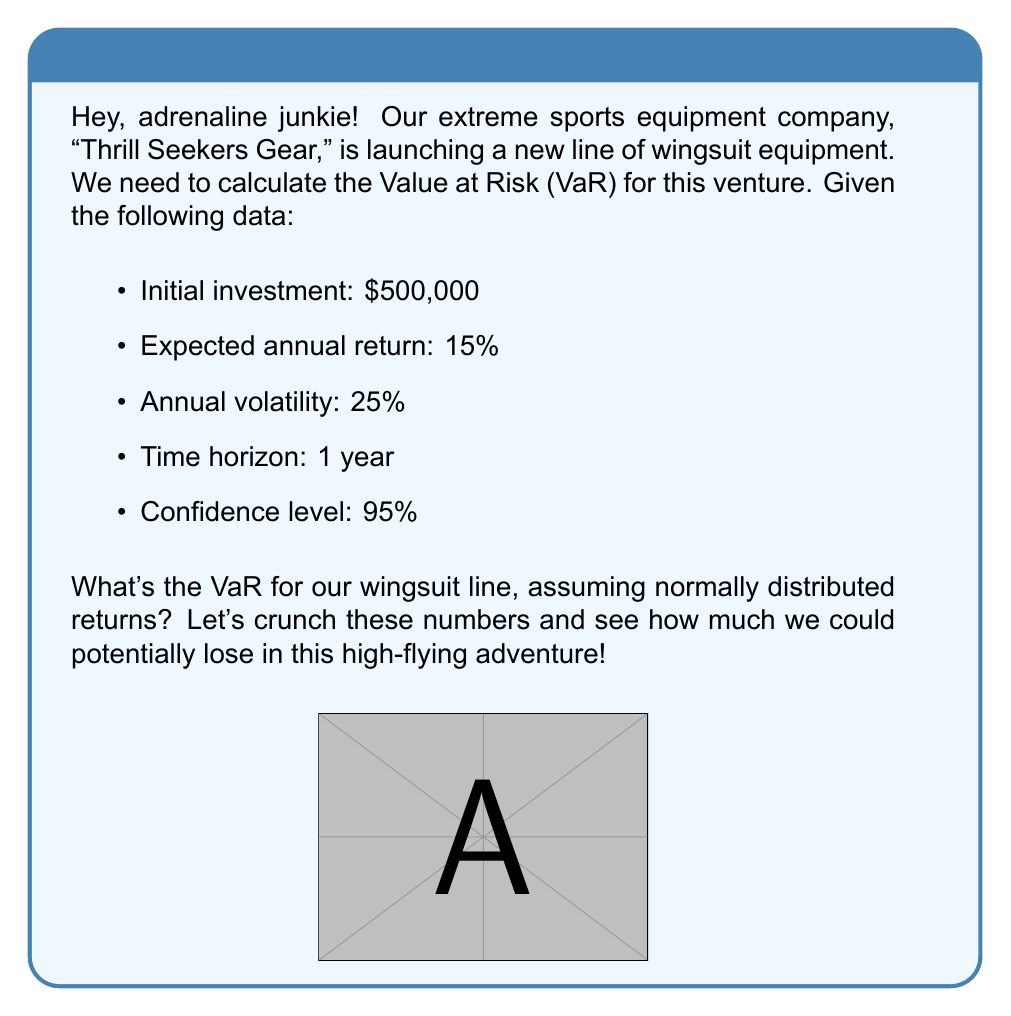Could you help me with this problem? Alright, fellow adventure seeker! Let's break this down step-by-step:

1) First, we need to recall the formula for Value at Risk (VaR) under normal distribution:

   $$ VaR = I \cdot (μ - z_α \cdot σ \cdot \sqrt{T}) $$

   Where:
   - $I$ is the initial investment
   - $μ$ is the expected return
   - $z_α$ is the z-score for the given confidence level
   - $σ$ is the volatility
   - $T$ is the time horizon in years

2) We have:
   - $I = \$500,000$
   - $μ = 15\% = 0.15$
   - $σ = 25\% = 0.25$
   - $T = 1$ year
   - Confidence level = 95%

3) For a 95% confidence level, the z-score is 1.645 (you can look this up in a standard normal distribution table).

4) Now, let's plug these values into our formula:

   $$ VaR = 500,000 \cdot (0.15 - 1.645 \cdot 0.25 \cdot \sqrt{1}) $$

5) Simplify:
   $$ VaR = 500,000 \cdot (0.15 - 1.645 \cdot 0.25) $$
   $$ VaR = 500,000 \cdot (0.15 - 0.41125) $$
   $$ VaR = 500,000 \cdot (-0.26125) $$
   $$ VaR = -130,625 $$

6) The negative sign indicates a potential loss. We typically express VaR as a positive number representing the potential loss.

Therefore, the Value at Risk for our wingsuit line is $130,625.
Answer: $130,625 